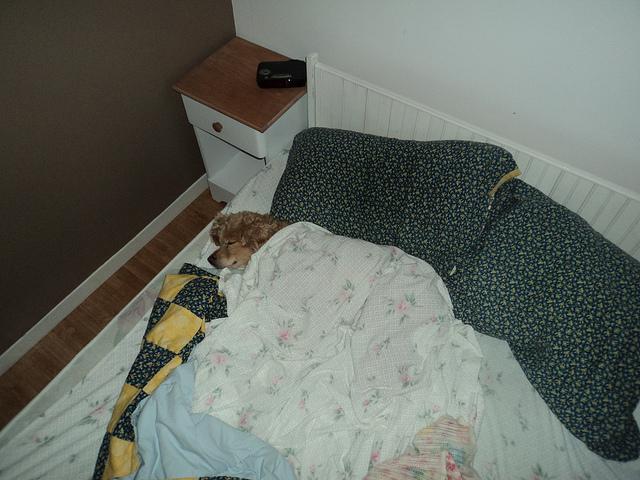Where is the dog going?
Concise answer only. To sleep. Is this a dog bed?
Answer briefly. No. What is the floor made of?
Short answer required. Wood. Is the dog sleeping?
Concise answer only. Yes. What is to the left of the bed?
Give a very brief answer. Dog. 